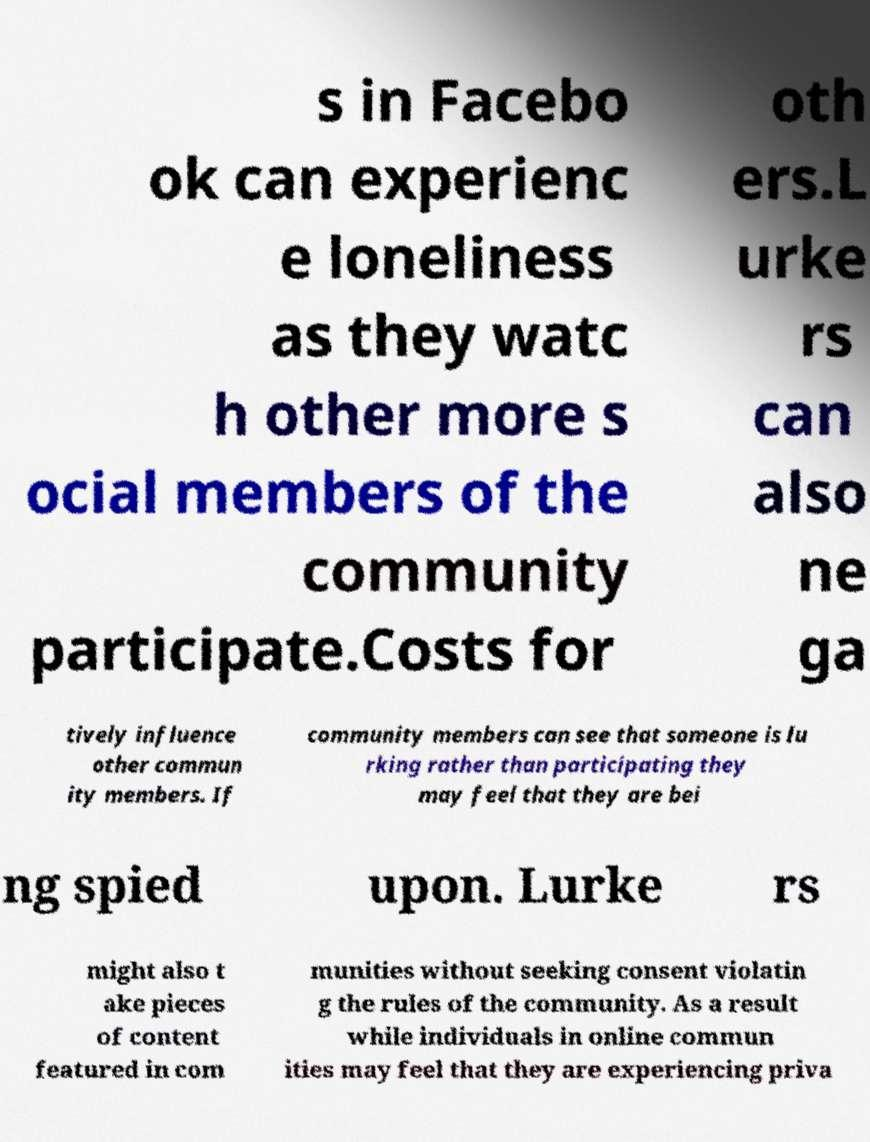For documentation purposes, I need the text within this image transcribed. Could you provide that? s in Facebo ok can experienc e loneliness as they watc h other more s ocial members of the community participate.Costs for oth ers.L urke rs can also ne ga tively influence other commun ity members. If community members can see that someone is lu rking rather than participating they may feel that they are bei ng spied upon. Lurke rs might also t ake pieces of content featured in com munities without seeking consent violatin g the rules of the community. As a result while individuals in online commun ities may feel that they are experiencing priva 